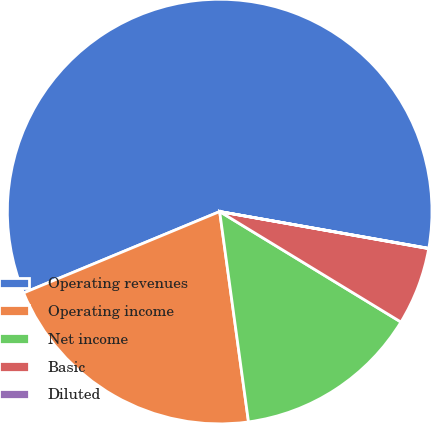Convert chart to OTSL. <chart><loc_0><loc_0><loc_500><loc_500><pie_chart><fcel>Operating revenues<fcel>Operating income<fcel>Net income<fcel>Basic<fcel>Diluted<nl><fcel>59.03%<fcel>20.91%<fcel>14.12%<fcel>5.92%<fcel>0.02%<nl></chart> 